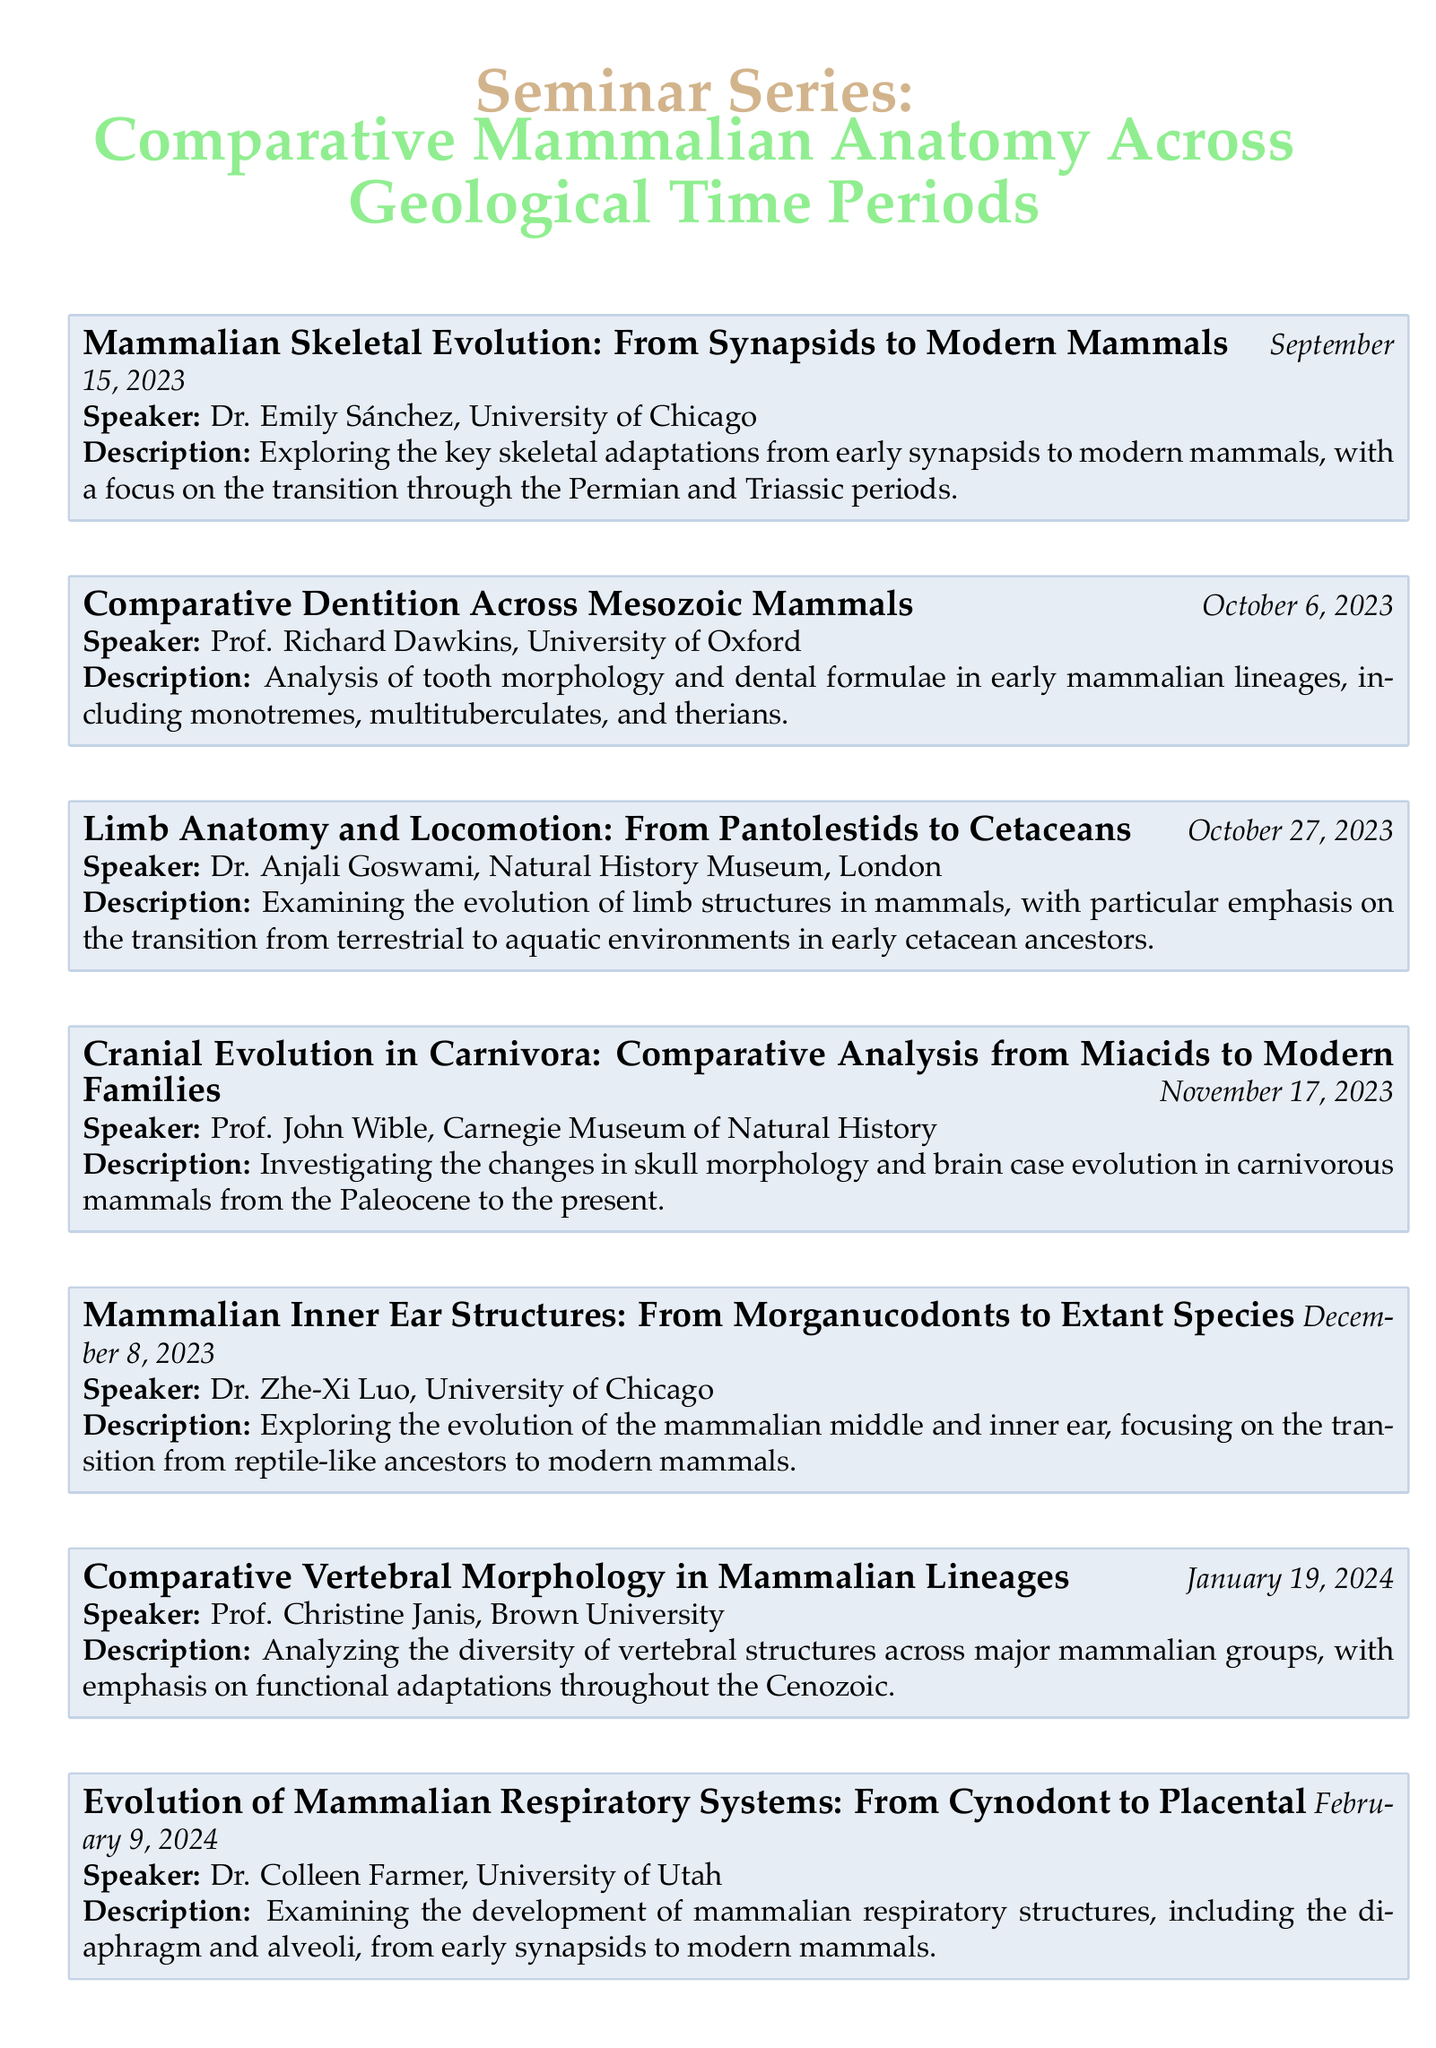What is the title of the first seminar? The title of the first seminar is listed at the beginning of the agenda, "Mammalian Skeletal Evolution: From Synapsids to Modern Mammals."
Answer: Mammalian Skeletal Evolution: From Synapsids to Modern Mammals Who is speaking at the seminar on October 27, 2023? The speaker for the seminar on this date is mentioned in the agenda, listed directly under the seminar title.
Answer: Dr. Anjali Goswami, Natural History Museum, London What is the date of the seminar on cranial evolution? The date for the cranial evolution seminar can be found next to its title in the document, indicating when it will take place.
Answer: November 17, 2023 Which institution is Dr. Marilyn Renfree associated with? Dr. Marilyn Renfree’s affiliation is provided in conjunction with her seminar title in the agenda.
Answer: University of Melbourne How many seminars are scheduled for the month of February? By reviewing the schedule, we can count the number of seminars listed for February, which is indicated by their dates.
Answer: One What is the main focus of the seminar titled "Comparative Neuroanatomy"? The focus of this seminar is summarized in the description provided in the agenda, outlining its main theme.
Answer: Brain Evolution in Mammals from Jurassic to Present Which two topics are covered by Dr. Zhe-Xi Luo? The topics associated with Dr. Zhe-Xi Luo's seminars can be found in the titles of the events he is presenting.
Answer: Mammalian Inner Ear Structures and Extant Species What type of anatomical structures does the seminar on February 9, 2024, examine? The specific anatomical structures analyzed in this seminar are detailed in the description, providing insight into the topics covered.
Answer: Respiratory Structures 